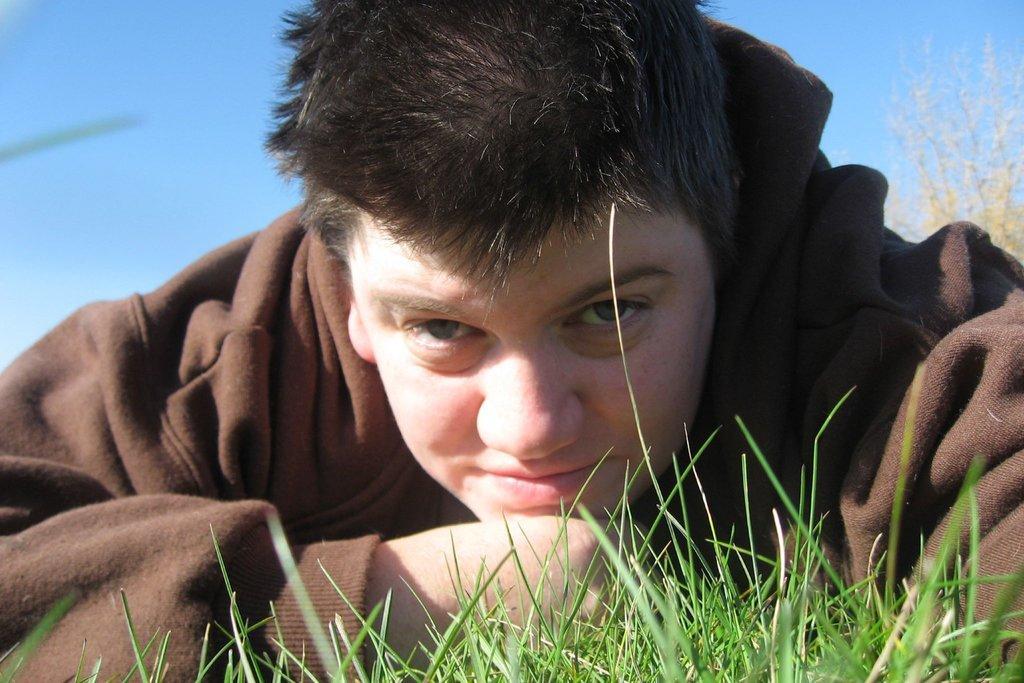Can you describe this image briefly? In the center of the image, we can see a person and at the bottom, there is grass and in the background, there are plants and there is sky. 